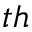<formula> <loc_0><loc_0><loc_500><loc_500>^ { t h }</formula> 